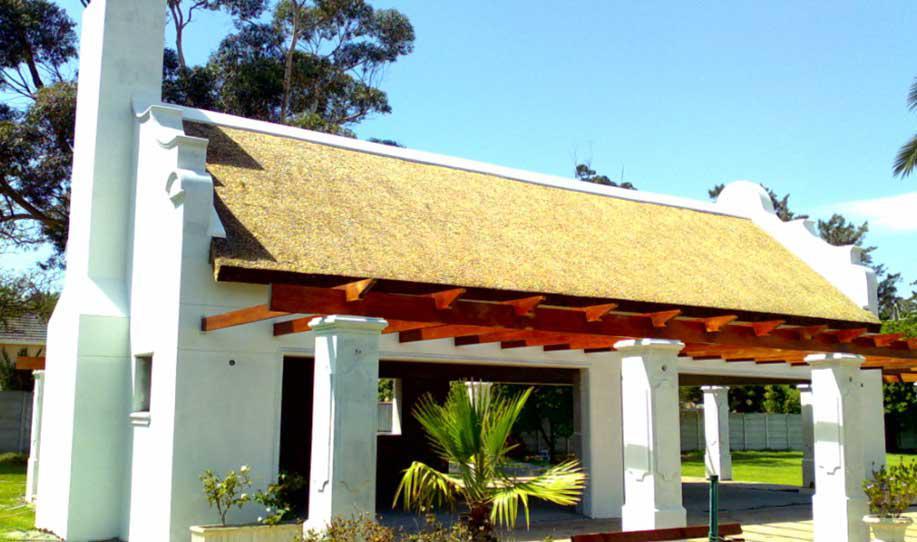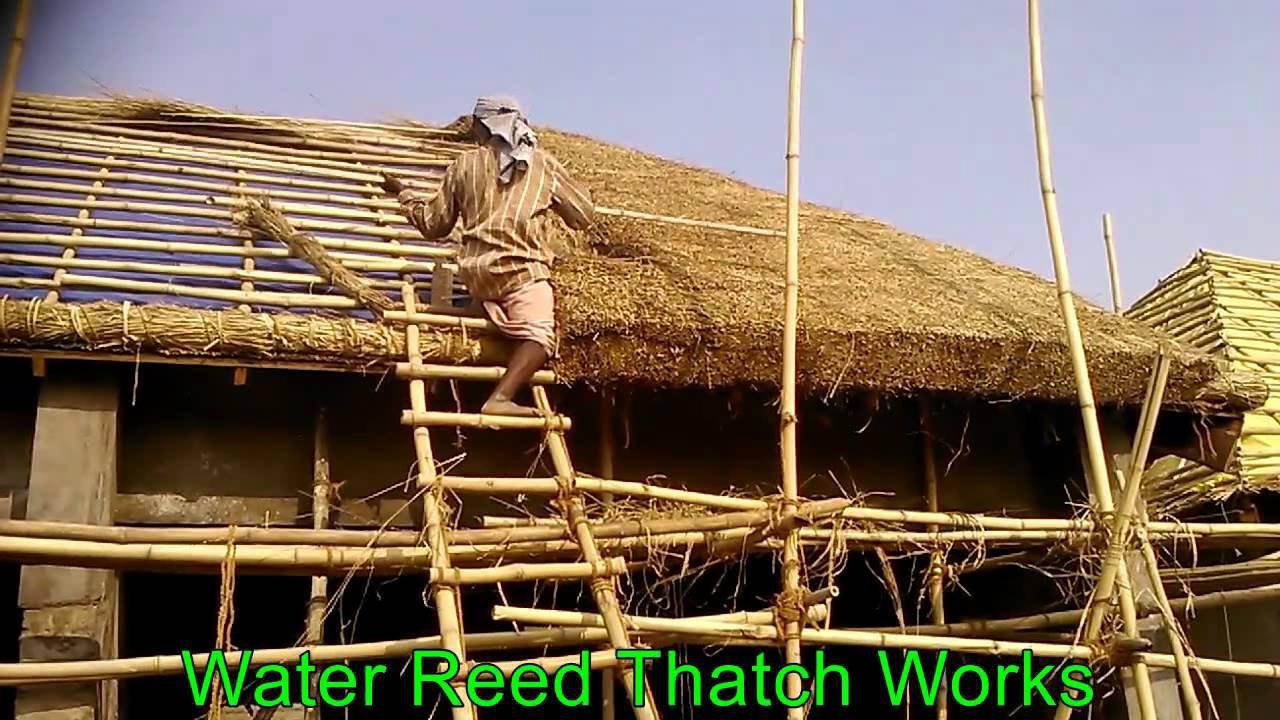The first image is the image on the left, the second image is the image on the right. Assess this claim about the two images: "A single man is working on the roof of the house in the image on the right.". Correct or not? Answer yes or no. Yes. The first image is the image on the left, the second image is the image on the right. Assess this claim about the two images: "The right image shows exactly one man on some type of platform in front of a sloped unfinished roof with at least one bundle of thatch propped on it and no chimney.". Correct or not? Answer yes or no. Yes. 